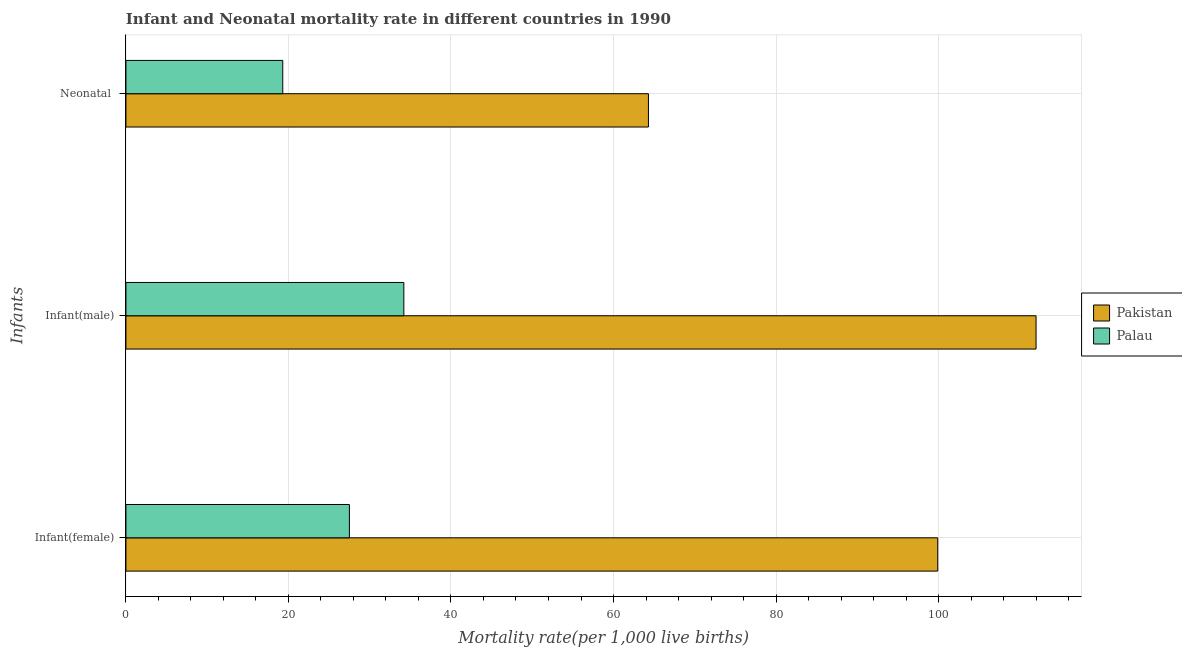How many different coloured bars are there?
Provide a short and direct response. 2. What is the label of the 3rd group of bars from the top?
Give a very brief answer. Infant(female). What is the infant mortality rate(male) in Palau?
Offer a terse response. 34.2. Across all countries, what is the maximum infant mortality rate(female)?
Offer a very short reply. 99.9. Across all countries, what is the minimum infant mortality rate(female)?
Ensure brevity in your answer.  27.5. In which country was the infant mortality rate(male) minimum?
Provide a succinct answer. Palau. What is the total infant mortality rate(male) in the graph?
Ensure brevity in your answer.  146.2. What is the difference between the neonatal mortality rate in Palau and that in Pakistan?
Provide a succinct answer. -45. What is the difference between the infant mortality rate(male) in Pakistan and the neonatal mortality rate in Palau?
Ensure brevity in your answer.  92.7. What is the average infant mortality rate(female) per country?
Ensure brevity in your answer.  63.7. What is the difference between the neonatal mortality rate and infant mortality rate(female) in Pakistan?
Give a very brief answer. -35.6. In how many countries, is the infant mortality rate(female) greater than 112 ?
Offer a terse response. 0. What is the ratio of the infant mortality rate(male) in Palau to that in Pakistan?
Your answer should be very brief. 0.31. Is the neonatal mortality rate in Pakistan less than that in Palau?
Provide a succinct answer. No. What is the difference between the highest and the second highest neonatal mortality rate?
Ensure brevity in your answer.  45. What is the difference between the highest and the lowest infant mortality rate(female)?
Your response must be concise. 72.4. In how many countries, is the infant mortality rate(female) greater than the average infant mortality rate(female) taken over all countries?
Give a very brief answer. 1. What does the 1st bar from the top in Neonatal  represents?
Provide a short and direct response. Palau. What does the 2nd bar from the bottom in Neonatal  represents?
Your answer should be compact. Palau. Are all the bars in the graph horizontal?
Offer a terse response. Yes. How many countries are there in the graph?
Your answer should be compact. 2. What is the difference between two consecutive major ticks on the X-axis?
Provide a succinct answer. 20. Are the values on the major ticks of X-axis written in scientific E-notation?
Give a very brief answer. No. Does the graph contain grids?
Keep it short and to the point. Yes. How many legend labels are there?
Offer a very short reply. 2. How are the legend labels stacked?
Your answer should be very brief. Vertical. What is the title of the graph?
Keep it short and to the point. Infant and Neonatal mortality rate in different countries in 1990. What is the label or title of the X-axis?
Provide a succinct answer. Mortality rate(per 1,0 live births). What is the label or title of the Y-axis?
Ensure brevity in your answer.  Infants. What is the Mortality rate(per 1,000 live births) of Pakistan in Infant(female)?
Your answer should be compact. 99.9. What is the Mortality rate(per 1,000 live births) in Pakistan in Infant(male)?
Offer a very short reply. 112. What is the Mortality rate(per 1,000 live births) in Palau in Infant(male)?
Offer a very short reply. 34.2. What is the Mortality rate(per 1,000 live births) of Pakistan in Neonatal ?
Give a very brief answer. 64.3. What is the Mortality rate(per 1,000 live births) in Palau in Neonatal ?
Give a very brief answer. 19.3. Across all Infants, what is the maximum Mortality rate(per 1,000 live births) of Pakistan?
Your response must be concise. 112. Across all Infants, what is the maximum Mortality rate(per 1,000 live births) in Palau?
Provide a succinct answer. 34.2. Across all Infants, what is the minimum Mortality rate(per 1,000 live births) in Pakistan?
Your answer should be compact. 64.3. Across all Infants, what is the minimum Mortality rate(per 1,000 live births) of Palau?
Your response must be concise. 19.3. What is the total Mortality rate(per 1,000 live births) in Pakistan in the graph?
Your response must be concise. 276.2. What is the difference between the Mortality rate(per 1,000 live births) of Pakistan in Infant(female) and that in Infant(male)?
Provide a short and direct response. -12.1. What is the difference between the Mortality rate(per 1,000 live births) in Palau in Infant(female) and that in Infant(male)?
Your answer should be very brief. -6.7. What is the difference between the Mortality rate(per 1,000 live births) of Pakistan in Infant(female) and that in Neonatal ?
Provide a short and direct response. 35.6. What is the difference between the Mortality rate(per 1,000 live births) of Palau in Infant(female) and that in Neonatal ?
Ensure brevity in your answer.  8.2. What is the difference between the Mortality rate(per 1,000 live births) of Pakistan in Infant(male) and that in Neonatal ?
Provide a succinct answer. 47.7. What is the difference between the Mortality rate(per 1,000 live births) of Pakistan in Infant(female) and the Mortality rate(per 1,000 live births) of Palau in Infant(male)?
Ensure brevity in your answer.  65.7. What is the difference between the Mortality rate(per 1,000 live births) of Pakistan in Infant(female) and the Mortality rate(per 1,000 live births) of Palau in Neonatal ?
Ensure brevity in your answer.  80.6. What is the difference between the Mortality rate(per 1,000 live births) in Pakistan in Infant(male) and the Mortality rate(per 1,000 live births) in Palau in Neonatal ?
Make the answer very short. 92.7. What is the average Mortality rate(per 1,000 live births) in Pakistan per Infants?
Offer a terse response. 92.07. What is the average Mortality rate(per 1,000 live births) in Palau per Infants?
Give a very brief answer. 27. What is the difference between the Mortality rate(per 1,000 live births) of Pakistan and Mortality rate(per 1,000 live births) of Palau in Infant(female)?
Keep it short and to the point. 72.4. What is the difference between the Mortality rate(per 1,000 live births) in Pakistan and Mortality rate(per 1,000 live births) in Palau in Infant(male)?
Keep it short and to the point. 77.8. What is the difference between the Mortality rate(per 1,000 live births) in Pakistan and Mortality rate(per 1,000 live births) in Palau in Neonatal ?
Offer a terse response. 45. What is the ratio of the Mortality rate(per 1,000 live births) in Pakistan in Infant(female) to that in Infant(male)?
Offer a very short reply. 0.89. What is the ratio of the Mortality rate(per 1,000 live births) in Palau in Infant(female) to that in Infant(male)?
Keep it short and to the point. 0.8. What is the ratio of the Mortality rate(per 1,000 live births) in Pakistan in Infant(female) to that in Neonatal ?
Ensure brevity in your answer.  1.55. What is the ratio of the Mortality rate(per 1,000 live births) in Palau in Infant(female) to that in Neonatal ?
Make the answer very short. 1.42. What is the ratio of the Mortality rate(per 1,000 live births) in Pakistan in Infant(male) to that in Neonatal ?
Provide a short and direct response. 1.74. What is the ratio of the Mortality rate(per 1,000 live births) in Palau in Infant(male) to that in Neonatal ?
Offer a very short reply. 1.77. What is the difference between the highest and the second highest Mortality rate(per 1,000 live births) of Pakistan?
Make the answer very short. 12.1. What is the difference between the highest and the lowest Mortality rate(per 1,000 live births) in Pakistan?
Your answer should be very brief. 47.7. What is the difference between the highest and the lowest Mortality rate(per 1,000 live births) in Palau?
Your answer should be very brief. 14.9. 